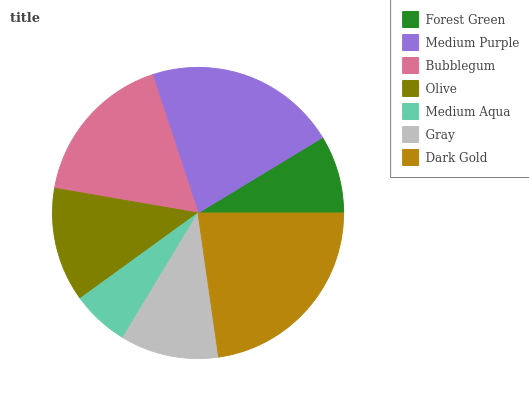Is Medium Aqua the minimum?
Answer yes or no. Yes. Is Dark Gold the maximum?
Answer yes or no. Yes. Is Medium Purple the minimum?
Answer yes or no. No. Is Medium Purple the maximum?
Answer yes or no. No. Is Medium Purple greater than Forest Green?
Answer yes or no. Yes. Is Forest Green less than Medium Purple?
Answer yes or no. Yes. Is Forest Green greater than Medium Purple?
Answer yes or no. No. Is Medium Purple less than Forest Green?
Answer yes or no. No. Is Olive the high median?
Answer yes or no. Yes. Is Olive the low median?
Answer yes or no. Yes. Is Bubblegum the high median?
Answer yes or no. No. Is Dark Gold the low median?
Answer yes or no. No. 